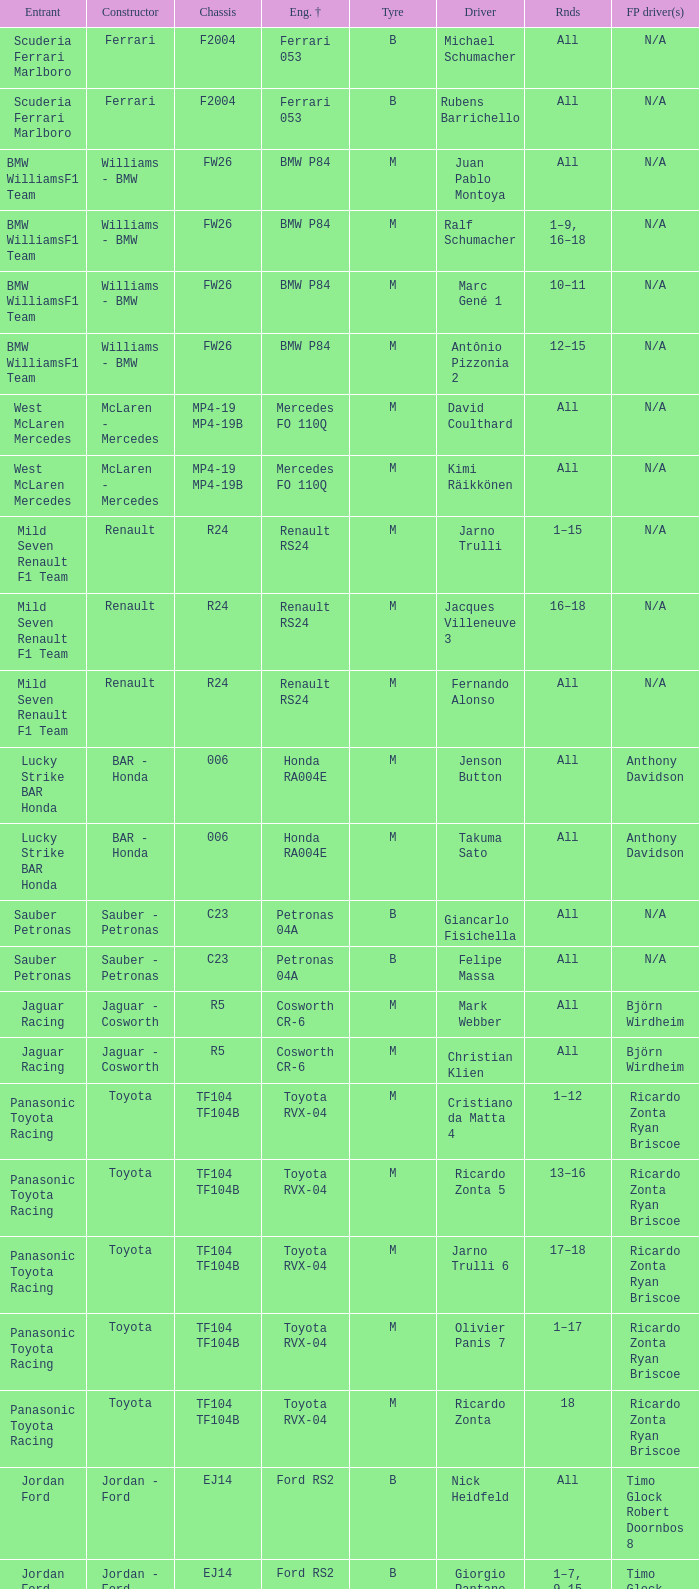What kind of chassis does Ricardo Zonta have? TF104 TF104B. 